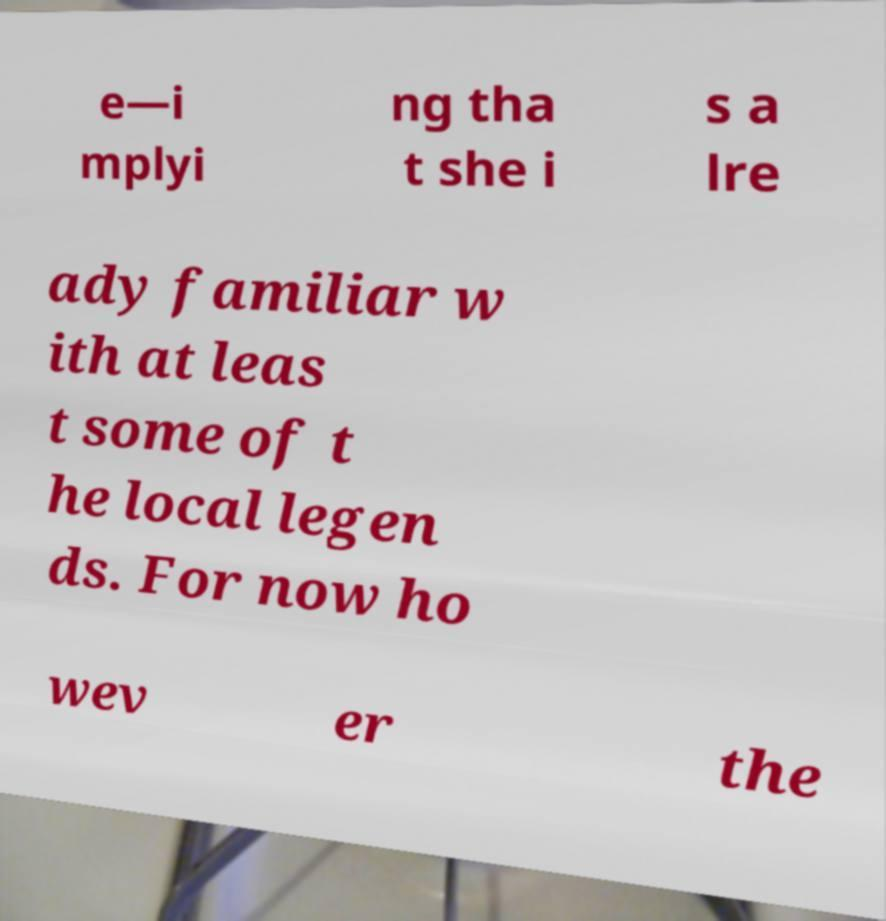For documentation purposes, I need the text within this image transcribed. Could you provide that? e—i mplyi ng tha t she i s a lre ady familiar w ith at leas t some of t he local legen ds. For now ho wev er the 